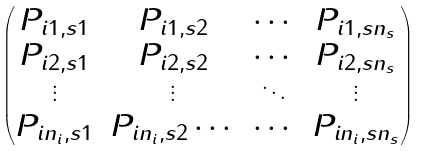Convert formula to latex. <formula><loc_0><loc_0><loc_500><loc_500>\begin{pmatrix} P _ { i 1 , s 1 } & P _ { i 1 , s 2 } & \cdots & P _ { i 1 , s n _ { s } } \\ P _ { i 2 , s 1 } & P _ { i 2 , s 2 } & \cdots & P _ { i 2 , s n _ { s } } \\ \vdots & \vdots & \ddots & \vdots \\ P _ { i n _ { i } , s 1 } & P _ { i n _ { i } , s 2 } \cdots & \cdots & P _ { i n _ { i } , s n _ { s } } \end{pmatrix}</formula> 